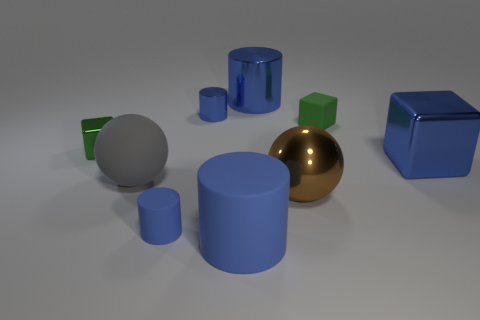Subtract all gray cylinders. Subtract all brown cubes. How many cylinders are left? 4 Add 1 large red cubes. How many objects exist? 10 Subtract all blocks. How many objects are left? 6 Subtract all big yellow matte spheres. Subtract all big rubber cylinders. How many objects are left? 8 Add 7 green matte things. How many green matte things are left? 8 Add 8 big cylinders. How many big cylinders exist? 10 Subtract 0 green balls. How many objects are left? 9 